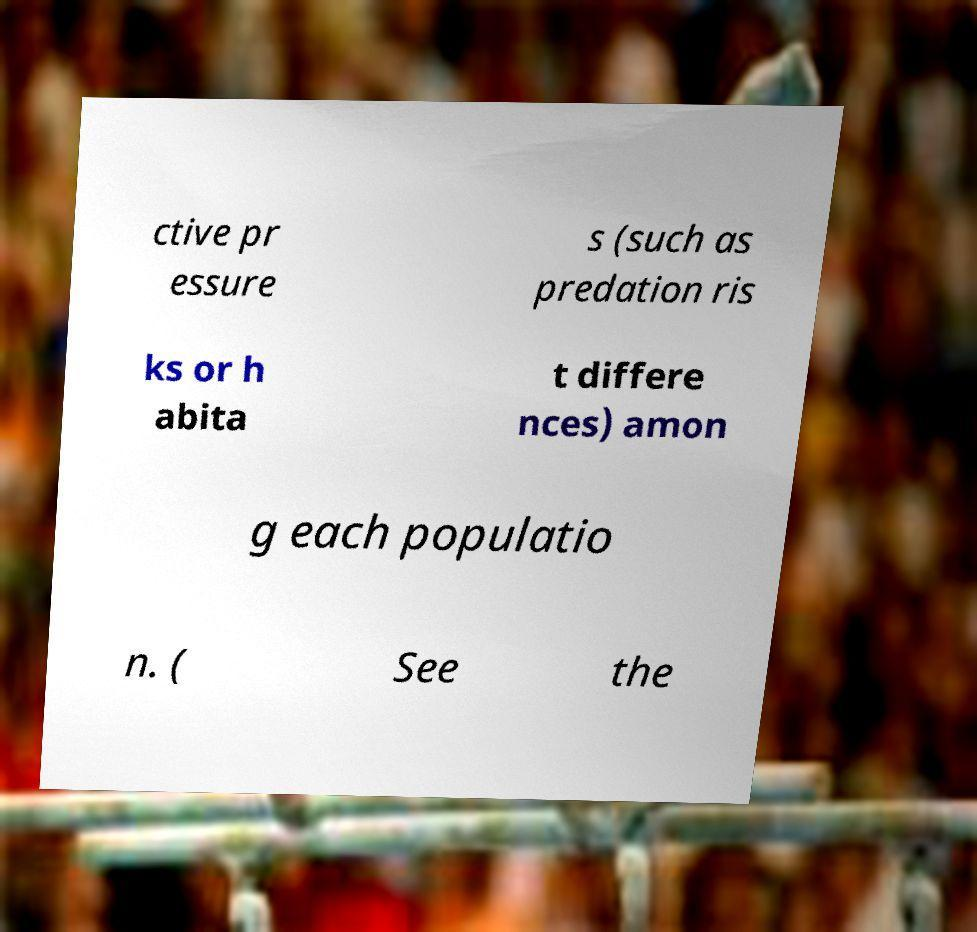What messages or text are displayed in this image? I need them in a readable, typed format. ctive pr essure s (such as predation ris ks or h abita t differe nces) amon g each populatio n. ( See the 